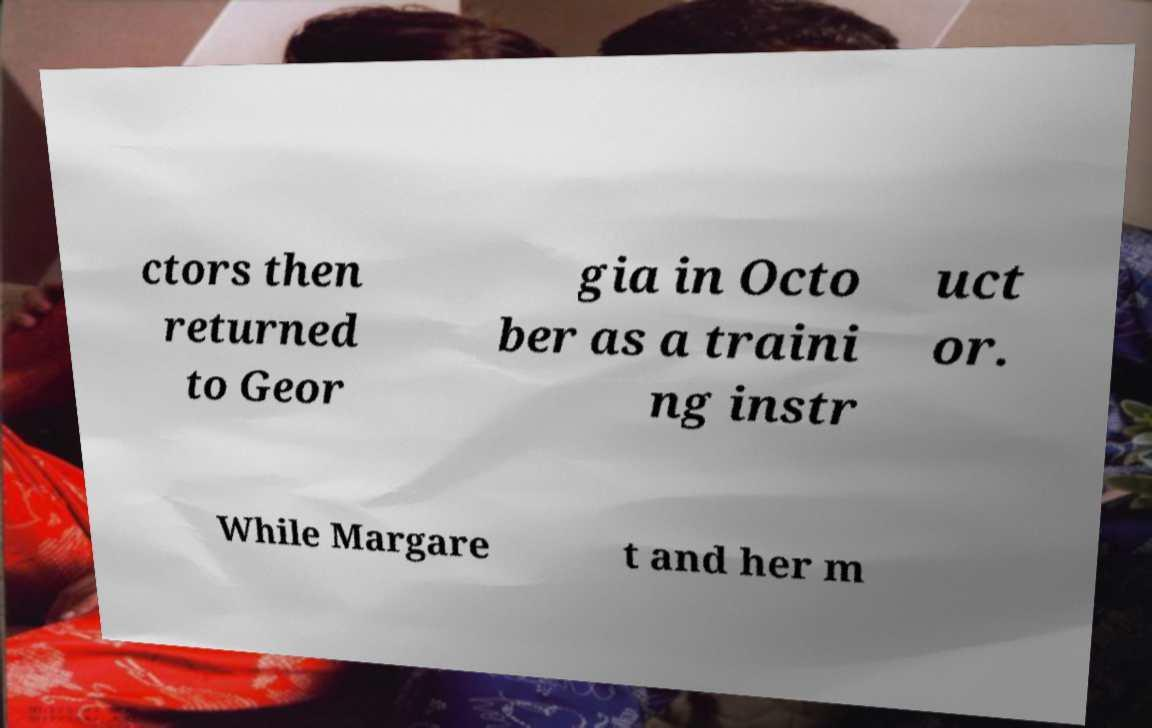There's text embedded in this image that I need extracted. Can you transcribe it verbatim? ctors then returned to Geor gia in Octo ber as a traini ng instr uct or. While Margare t and her m 